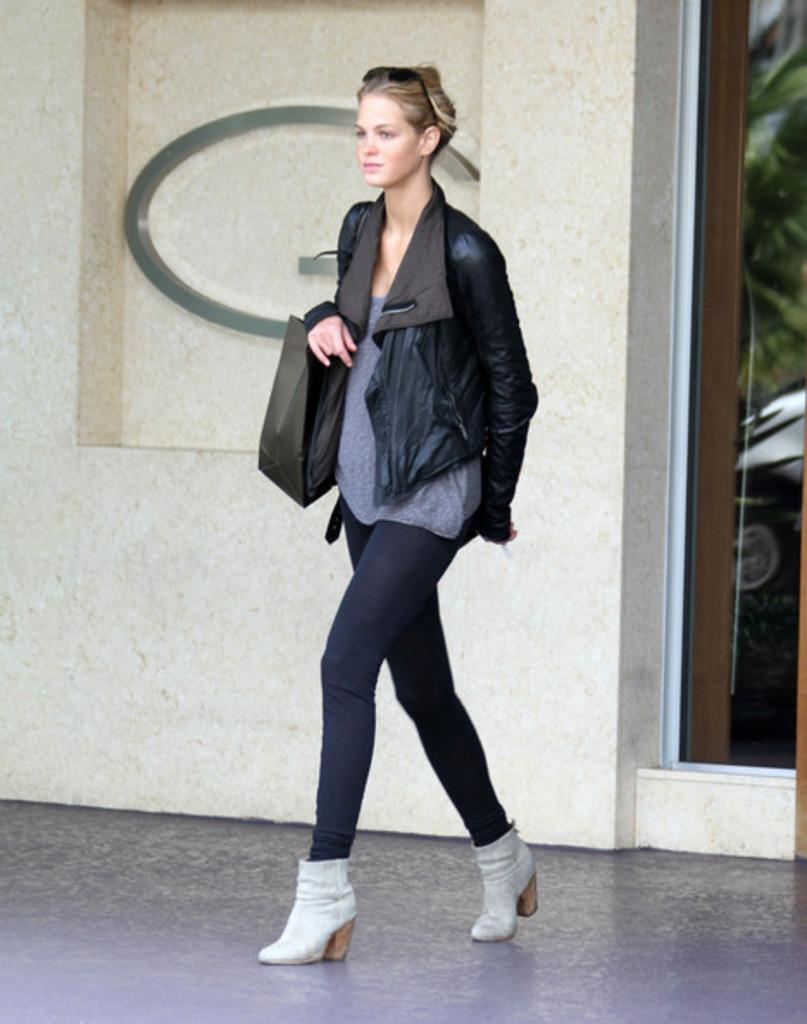Who is the main subject in the image? There is a girl in the image. What is the girl wearing? The girl is wearing a black jacket. What is the girl holding in her right hand? The girl is holding a black bag in her right hand. What can be seen in the background of the image? There is a wall in the image. What is attached to the wall? There is a metal object attached to the wall. What title is the girl reading in the image? There is no book or title visible in the image; the girl is holding a black bag in her right hand. 